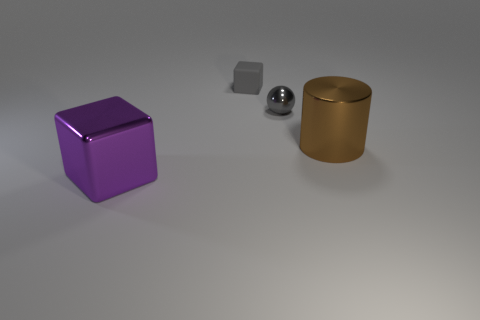Add 3 large metallic cylinders. How many objects exist? 7 Subtract all balls. How many objects are left? 3 Subtract all purple spheres. Subtract all large metallic blocks. How many objects are left? 3 Add 3 purple blocks. How many purple blocks are left? 4 Add 1 small purple things. How many small purple things exist? 1 Subtract 0 red balls. How many objects are left? 4 